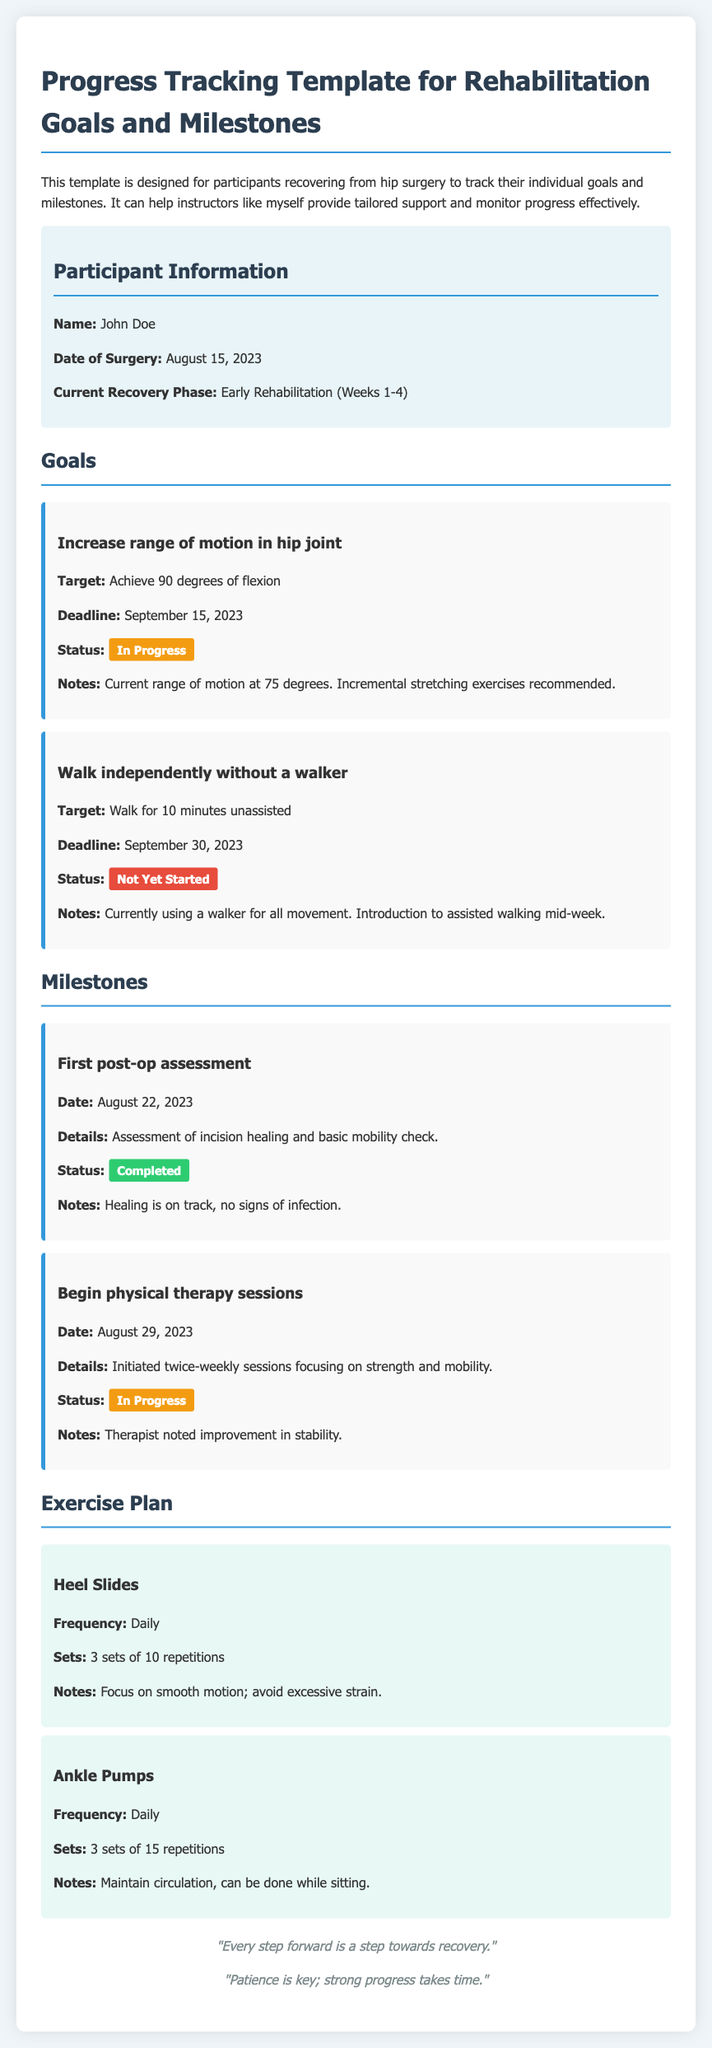What is the participant's name? The name of the participant is found in the participant information section.
Answer: John Doe When was the surgery date? The surgery date is located in the participant information section.
Answer: August 15, 2023 What is the target for the range of motion goal? The target for the range of motion goal can be found under the goals section.
Answer: Achieve 90 degrees of flexion What is the status of the goal to walk independently? The status indicates whether the goal has been started, in progress, or completed, found under the goals section.
Answer: Not Yet Started What is the date of the first post-op assessment? This date is listed under the milestones section.
Answer: August 22, 2023 How many sets are recommended for Heel Slides? The number of sets for the exercise can be found in the exercise plan section.
Answer: 3 sets What is the status of the "Begin physical therapy sessions" milestone? The status indicates if the milestone is completed, in progress, or not started, and can be found in the milestones section.
Answer: In Progress What is the frequency of Ankle Pumps? The frequency of the exercise is given in the exercise plan section.
Answer: Daily 